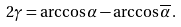Convert formula to latex. <formula><loc_0><loc_0><loc_500><loc_500>2 \gamma = \arccos \alpha - \arccos \overline { \alpha } \, .</formula> 